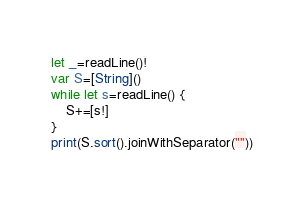<code> <loc_0><loc_0><loc_500><loc_500><_Swift_>let _=readLine()!
var S=[String]()
while let s=readLine() {
    S+=[s!]
}
print(S.sort().joinWithSeparator(""))</code> 